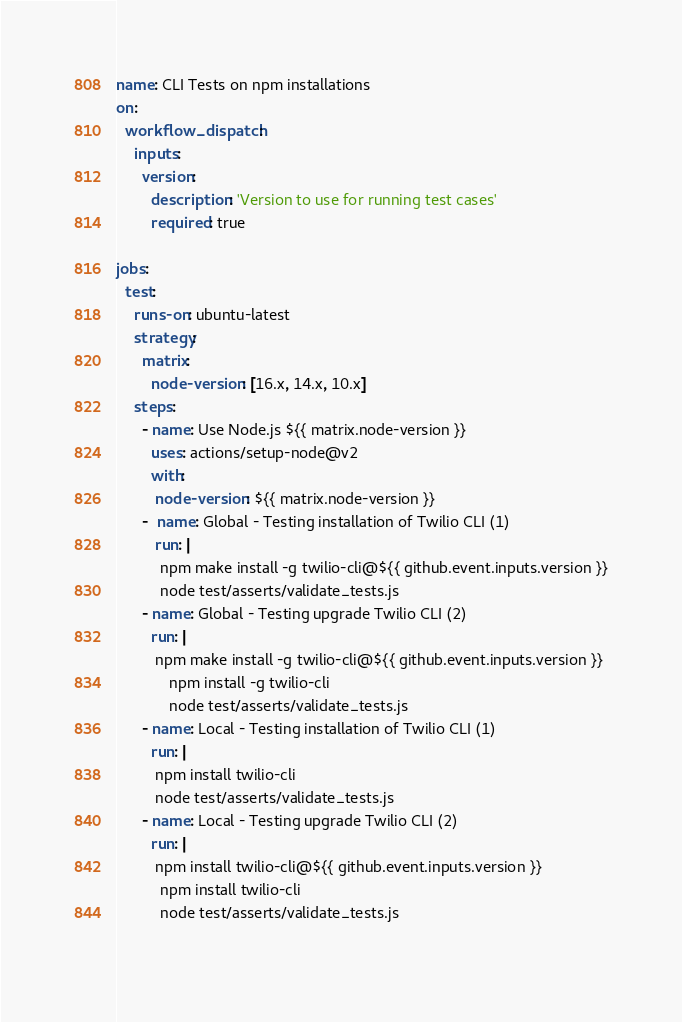<code> <loc_0><loc_0><loc_500><loc_500><_YAML_>name: CLI Tests on npm installations
on:
  workflow_dispatch:
    inputs:
      version:
        description: 'Version to use for running test cases'
        required: true

jobs:
  test:
    runs-on: ubuntu-latest
    strategy:
      matrix:
        node-version: [16.x, 14.x, 10.x]
    steps:
      - name: Use Node.js ${{ matrix.node-version }}
        uses: actions/setup-node@v2
        with:
         node-version: ${{ matrix.node-version }}
      -  name: Global - Testing installation of Twilio CLI (1)
         run: |
          npm make install -g twilio-cli@${{ github.event.inputs.version }}
          node test/asserts/validate_tests.js
      - name: Global - Testing upgrade Twilio CLI (2)
        run: |
         npm make install -g twilio-cli@${{ github.event.inputs.version }}
            npm install -g twilio-cli
            node test/asserts/validate_tests.js
      - name: Local - Testing installation of Twilio CLI (1)
        run: |
         npm install twilio-cli
         node test/asserts/validate_tests.js
      - name: Local - Testing upgrade Twilio CLI (2)
        run: |
         npm install twilio-cli@${{ github.event.inputs.version }}
          npm install twilio-cli
          node test/asserts/validate_tests.js
          
</code> 